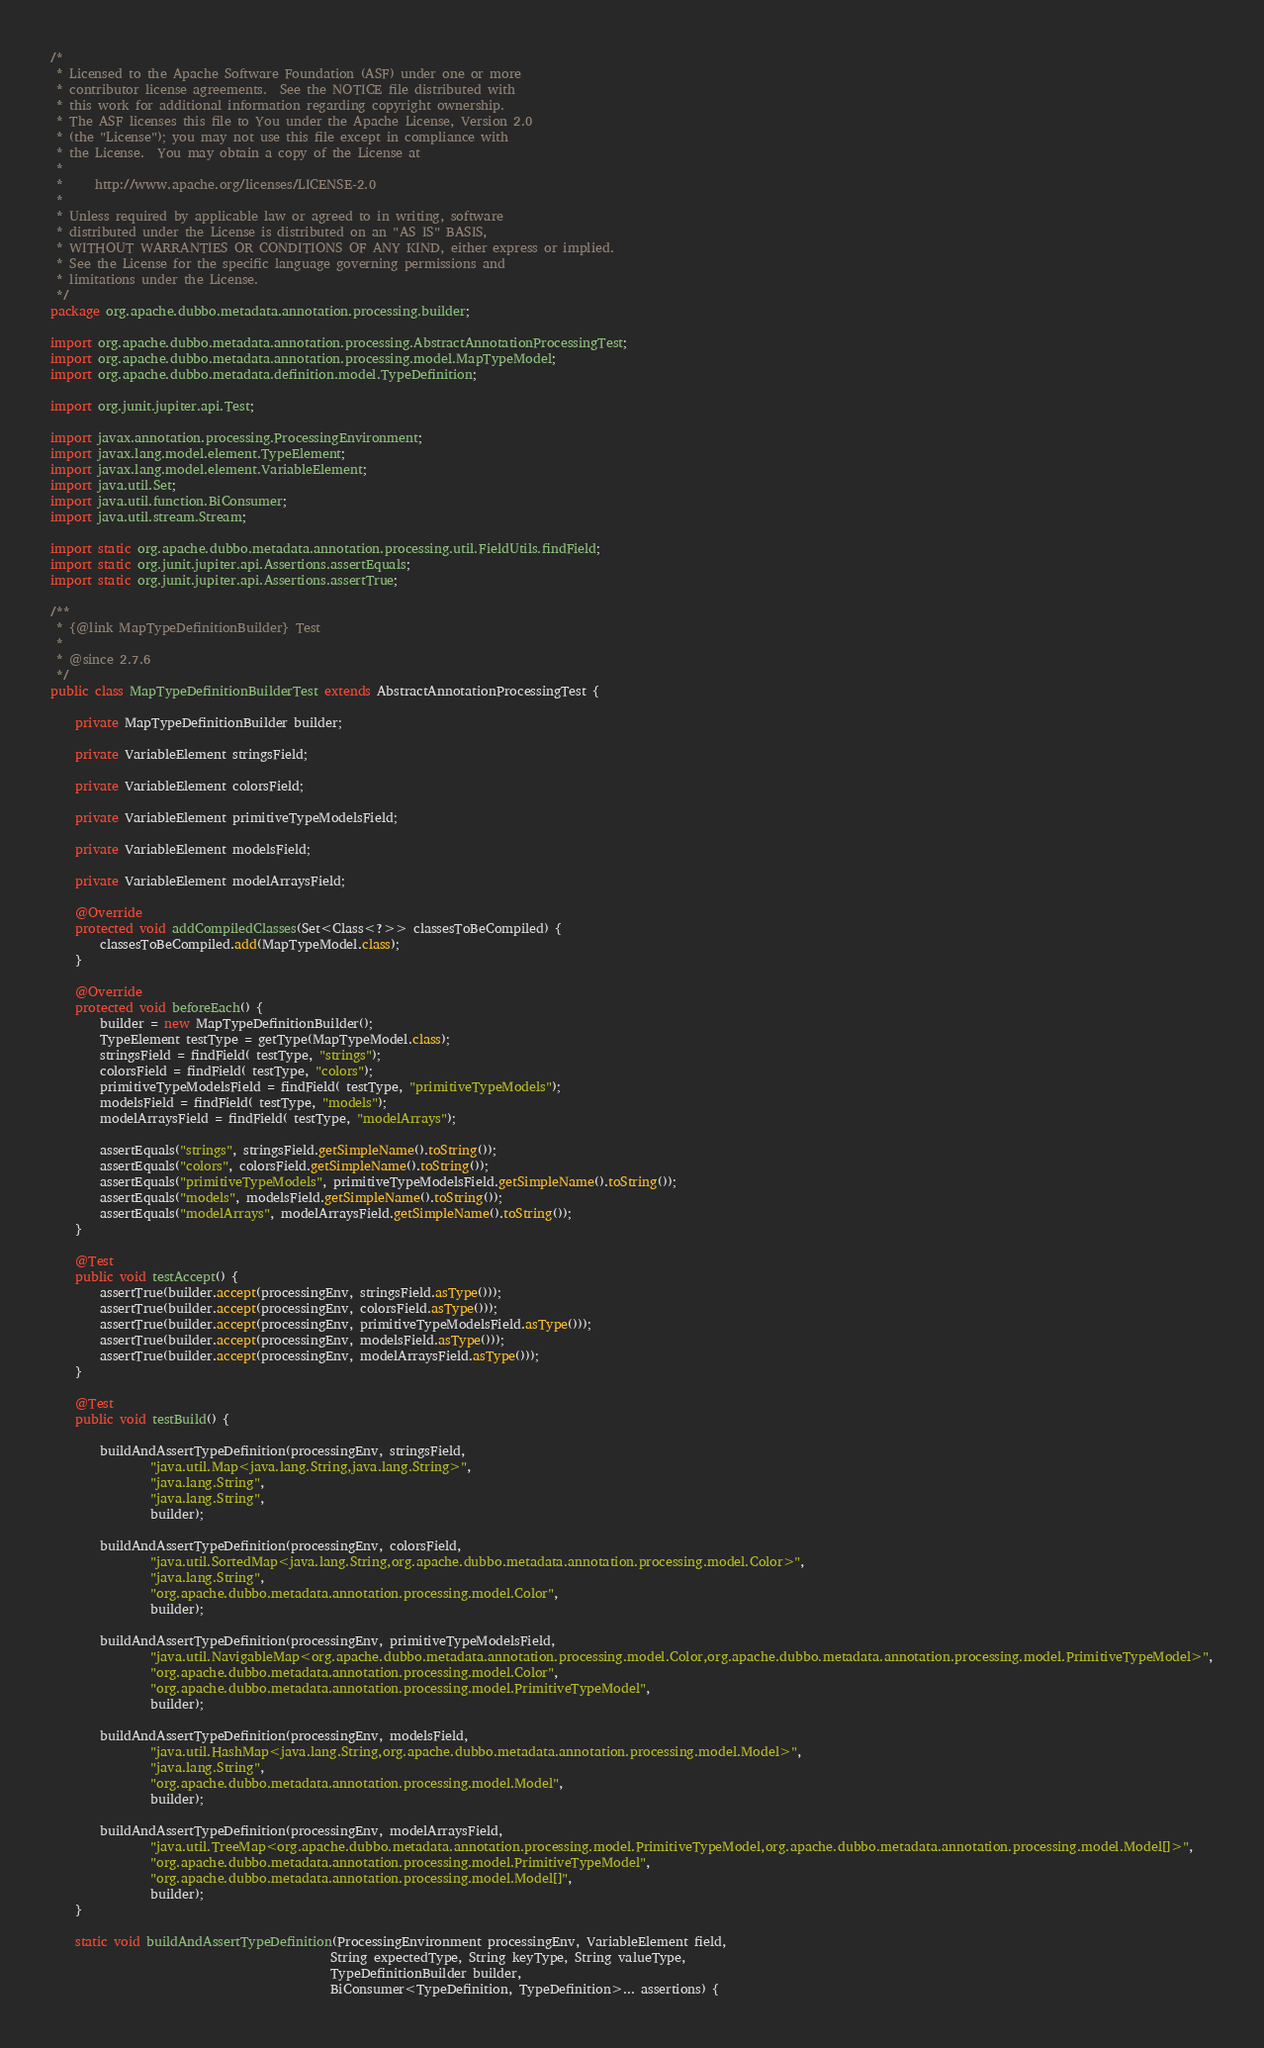Convert code to text. <code><loc_0><loc_0><loc_500><loc_500><_Java_>/*
 * Licensed to the Apache Software Foundation (ASF) under one or more
 * contributor license agreements.  See the NOTICE file distributed with
 * this work for additional information regarding copyright ownership.
 * The ASF licenses this file to You under the Apache License, Version 2.0
 * (the "License"); you may not use this file except in compliance with
 * the License.  You may obtain a copy of the License at
 *
 *     http://www.apache.org/licenses/LICENSE-2.0
 *
 * Unless required by applicable law or agreed to in writing, software
 * distributed under the License is distributed on an "AS IS" BASIS,
 * WITHOUT WARRANTIES OR CONDITIONS OF ANY KIND, either express or implied.
 * See the License for the specific language governing permissions and
 * limitations under the License.
 */
package org.apache.dubbo.metadata.annotation.processing.builder;

import org.apache.dubbo.metadata.annotation.processing.AbstractAnnotationProcessingTest;
import org.apache.dubbo.metadata.annotation.processing.model.MapTypeModel;
import org.apache.dubbo.metadata.definition.model.TypeDefinition;

import org.junit.jupiter.api.Test;

import javax.annotation.processing.ProcessingEnvironment;
import javax.lang.model.element.TypeElement;
import javax.lang.model.element.VariableElement;
import java.util.Set;
import java.util.function.BiConsumer;
import java.util.stream.Stream;

import static org.apache.dubbo.metadata.annotation.processing.util.FieldUtils.findField;
import static org.junit.jupiter.api.Assertions.assertEquals;
import static org.junit.jupiter.api.Assertions.assertTrue;

/**
 * {@link MapTypeDefinitionBuilder} Test
 *
 * @since 2.7.6
 */
public class MapTypeDefinitionBuilderTest extends AbstractAnnotationProcessingTest {

    private MapTypeDefinitionBuilder builder;

    private VariableElement stringsField;

    private VariableElement colorsField;

    private VariableElement primitiveTypeModelsField;

    private VariableElement modelsField;

    private VariableElement modelArraysField;

    @Override
    protected void addCompiledClasses(Set<Class<?>> classesToBeCompiled) {
        classesToBeCompiled.add(MapTypeModel.class);
    }

    @Override
    protected void beforeEach() {
        builder = new MapTypeDefinitionBuilder();
        TypeElement testType = getType(MapTypeModel.class);
        stringsField = findField( testType, "strings");
        colorsField = findField( testType, "colors");
        primitiveTypeModelsField = findField( testType, "primitiveTypeModels");
        modelsField = findField( testType, "models");
        modelArraysField = findField( testType, "modelArrays");

        assertEquals("strings", stringsField.getSimpleName().toString());
        assertEquals("colors", colorsField.getSimpleName().toString());
        assertEquals("primitiveTypeModels", primitiveTypeModelsField.getSimpleName().toString());
        assertEquals("models", modelsField.getSimpleName().toString());
        assertEquals("modelArrays", modelArraysField.getSimpleName().toString());
    }

    @Test
    public void testAccept() {
        assertTrue(builder.accept(processingEnv, stringsField.asType()));
        assertTrue(builder.accept(processingEnv, colorsField.asType()));
        assertTrue(builder.accept(processingEnv, primitiveTypeModelsField.asType()));
        assertTrue(builder.accept(processingEnv, modelsField.asType()));
        assertTrue(builder.accept(processingEnv, modelArraysField.asType()));
    }

    @Test
    public void testBuild() {

        buildAndAssertTypeDefinition(processingEnv, stringsField,
                "java.util.Map<java.lang.String,java.lang.String>",
                "java.lang.String",
                "java.lang.String",
                builder);

        buildAndAssertTypeDefinition(processingEnv, colorsField,
                "java.util.SortedMap<java.lang.String,org.apache.dubbo.metadata.annotation.processing.model.Color>",
                "java.lang.String",
                "org.apache.dubbo.metadata.annotation.processing.model.Color",
                builder);

        buildAndAssertTypeDefinition(processingEnv, primitiveTypeModelsField,
                "java.util.NavigableMap<org.apache.dubbo.metadata.annotation.processing.model.Color,org.apache.dubbo.metadata.annotation.processing.model.PrimitiveTypeModel>",
                "org.apache.dubbo.metadata.annotation.processing.model.Color",
                "org.apache.dubbo.metadata.annotation.processing.model.PrimitiveTypeModel",
                builder);

        buildAndAssertTypeDefinition(processingEnv, modelsField,
                "java.util.HashMap<java.lang.String,org.apache.dubbo.metadata.annotation.processing.model.Model>",
                "java.lang.String",
                "org.apache.dubbo.metadata.annotation.processing.model.Model",
                builder);

        buildAndAssertTypeDefinition(processingEnv, modelArraysField,
                "java.util.TreeMap<org.apache.dubbo.metadata.annotation.processing.model.PrimitiveTypeModel,org.apache.dubbo.metadata.annotation.processing.model.Model[]>",
                "org.apache.dubbo.metadata.annotation.processing.model.PrimitiveTypeModel",
                "org.apache.dubbo.metadata.annotation.processing.model.Model[]",
                builder);
    }

    static void buildAndAssertTypeDefinition(ProcessingEnvironment processingEnv, VariableElement field,
                                             String expectedType, String keyType, String valueType,
                                             TypeDefinitionBuilder builder,
                                             BiConsumer<TypeDefinition, TypeDefinition>... assertions) {</code> 